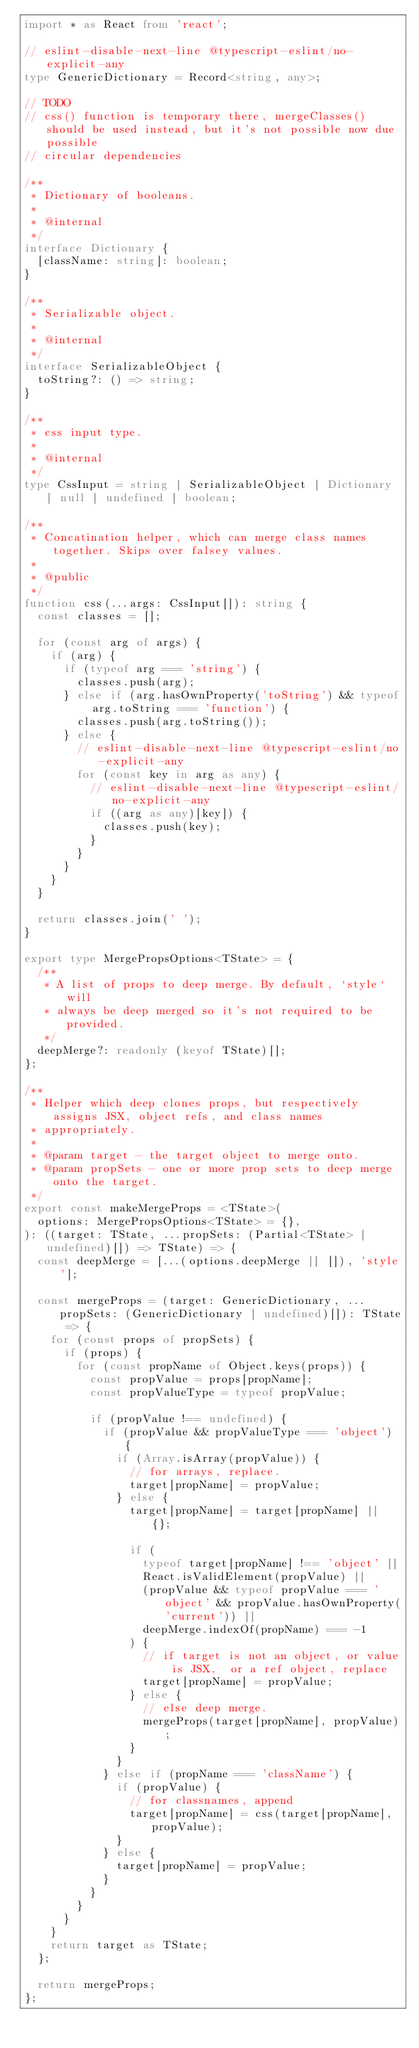Convert code to text. <code><loc_0><loc_0><loc_500><loc_500><_TypeScript_>import * as React from 'react';

// eslint-disable-next-line @typescript-eslint/no-explicit-any
type GenericDictionary = Record<string, any>;

// TODO
// css() function is temporary there, mergeClasses() should be used instead, but it's not possible now due possible
// circular dependencies

/**
 * Dictionary of booleans.
 *
 * @internal
 */
interface Dictionary {
  [className: string]: boolean;
}

/**
 * Serializable object.
 *
 * @internal
 */
interface SerializableObject {
  toString?: () => string;
}

/**
 * css input type.
 *
 * @internal
 */
type CssInput = string | SerializableObject | Dictionary | null | undefined | boolean;

/**
 * Concatination helper, which can merge class names together. Skips over falsey values.
 *
 * @public
 */
function css(...args: CssInput[]): string {
  const classes = [];

  for (const arg of args) {
    if (arg) {
      if (typeof arg === 'string') {
        classes.push(arg);
      } else if (arg.hasOwnProperty('toString') && typeof arg.toString === 'function') {
        classes.push(arg.toString());
      } else {
        // eslint-disable-next-line @typescript-eslint/no-explicit-any
        for (const key in arg as any) {
          // eslint-disable-next-line @typescript-eslint/no-explicit-any
          if ((arg as any)[key]) {
            classes.push(key);
          }
        }
      }
    }
  }

  return classes.join(' ');
}

export type MergePropsOptions<TState> = {
  /**
   * A list of props to deep merge. By default, `style` will
   * always be deep merged so it's not required to be provided.
   */
  deepMerge?: readonly (keyof TState)[];
};

/**
 * Helper which deep clones props, but respectively assigns JSX, object refs, and class names
 * appropriately.
 *
 * @param target - the target object to merge onto.
 * @param propSets - one or more prop sets to deep merge onto the target.
 */
export const makeMergeProps = <TState>(
  options: MergePropsOptions<TState> = {},
): ((target: TState, ...propSets: (Partial<TState> | undefined)[]) => TState) => {
  const deepMerge = [...(options.deepMerge || []), 'style'];

  const mergeProps = (target: GenericDictionary, ...propSets: (GenericDictionary | undefined)[]): TState => {
    for (const props of propSets) {
      if (props) {
        for (const propName of Object.keys(props)) {
          const propValue = props[propName];
          const propValueType = typeof propValue;

          if (propValue !== undefined) {
            if (propValue && propValueType === 'object') {
              if (Array.isArray(propValue)) {
                // for arrays, replace.
                target[propName] = propValue;
              } else {
                target[propName] = target[propName] || {};

                if (
                  typeof target[propName] !== 'object' ||
                  React.isValidElement(propValue) ||
                  (propValue && typeof propValue === 'object' && propValue.hasOwnProperty('current')) ||
                  deepMerge.indexOf(propName) === -1
                ) {
                  // if target is not an object, or value is JSX,  or a ref object, replace
                  target[propName] = propValue;
                } else {
                  // else deep merge.
                  mergeProps(target[propName], propValue);
                }
              }
            } else if (propName === 'className') {
              if (propValue) {
                // for classnames, append
                target[propName] = css(target[propName], propValue);
              }
            } else {
              target[propName] = propValue;
            }
          }
        }
      }
    }
    return target as TState;
  };

  return mergeProps;
};
</code> 